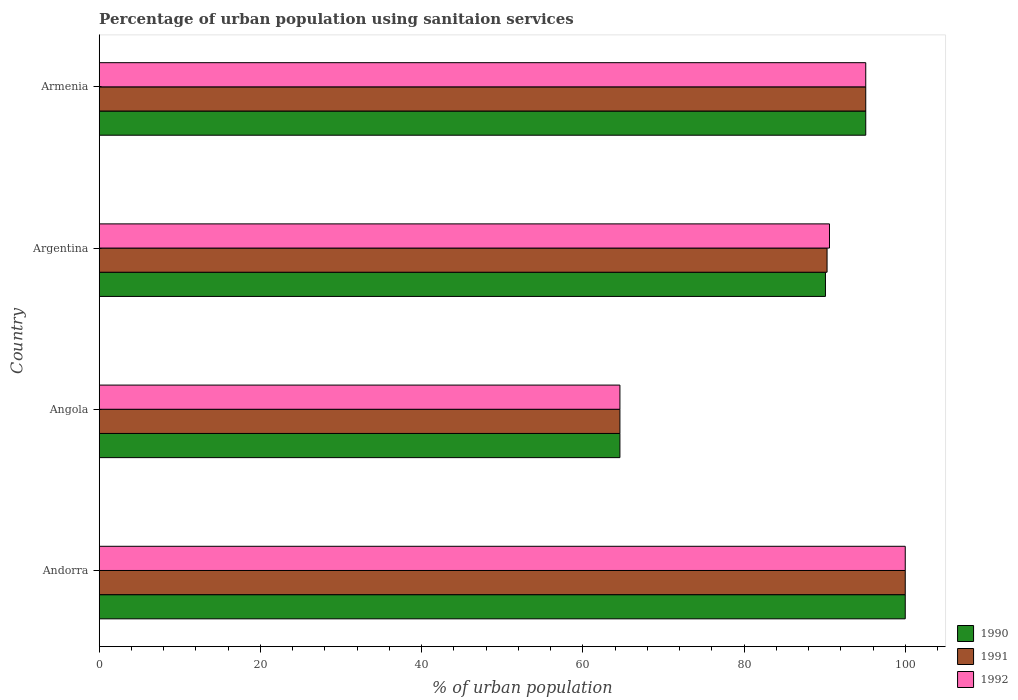How many different coloured bars are there?
Provide a short and direct response. 3. Are the number of bars per tick equal to the number of legend labels?
Keep it short and to the point. Yes. How many bars are there on the 4th tick from the top?
Make the answer very short. 3. How many bars are there on the 1st tick from the bottom?
Your response must be concise. 3. What is the label of the 2nd group of bars from the top?
Keep it short and to the point. Argentina. In how many cases, is the number of bars for a given country not equal to the number of legend labels?
Your answer should be very brief. 0. What is the percentage of urban population using sanitaion services in 1991 in Angola?
Your answer should be very brief. 64.6. Across all countries, what is the maximum percentage of urban population using sanitaion services in 1992?
Provide a succinct answer. 100. Across all countries, what is the minimum percentage of urban population using sanitaion services in 1990?
Keep it short and to the point. 64.6. In which country was the percentage of urban population using sanitaion services in 1991 maximum?
Your answer should be very brief. Andorra. In which country was the percentage of urban population using sanitaion services in 1992 minimum?
Provide a succinct answer. Angola. What is the total percentage of urban population using sanitaion services in 1991 in the graph?
Offer a terse response. 350. What is the difference between the percentage of urban population using sanitaion services in 1991 in Argentina and that in Armenia?
Offer a terse response. -4.8. What is the difference between the percentage of urban population using sanitaion services in 1992 in Argentina and the percentage of urban population using sanitaion services in 1990 in Andorra?
Provide a short and direct response. -9.4. What is the average percentage of urban population using sanitaion services in 1991 per country?
Offer a terse response. 87.5. What is the difference between the percentage of urban population using sanitaion services in 1990 and percentage of urban population using sanitaion services in 1992 in Argentina?
Provide a succinct answer. -0.5. In how many countries, is the percentage of urban population using sanitaion services in 1990 greater than 12 %?
Offer a terse response. 4. What is the ratio of the percentage of urban population using sanitaion services in 1991 in Andorra to that in Armenia?
Provide a short and direct response. 1.05. What is the difference between the highest and the second highest percentage of urban population using sanitaion services in 1990?
Your answer should be compact. 4.9. What is the difference between the highest and the lowest percentage of urban population using sanitaion services in 1990?
Ensure brevity in your answer.  35.4. In how many countries, is the percentage of urban population using sanitaion services in 1992 greater than the average percentage of urban population using sanitaion services in 1992 taken over all countries?
Offer a very short reply. 3. Is the sum of the percentage of urban population using sanitaion services in 1990 in Angola and Armenia greater than the maximum percentage of urban population using sanitaion services in 1992 across all countries?
Your answer should be compact. Yes. What does the 3rd bar from the top in Andorra represents?
Keep it short and to the point. 1990. What does the 1st bar from the bottom in Andorra represents?
Your answer should be compact. 1990. How many bars are there?
Your answer should be very brief. 12. Are all the bars in the graph horizontal?
Your answer should be very brief. Yes. Are the values on the major ticks of X-axis written in scientific E-notation?
Offer a very short reply. No. How many legend labels are there?
Provide a succinct answer. 3. What is the title of the graph?
Your answer should be compact. Percentage of urban population using sanitaion services. What is the label or title of the X-axis?
Make the answer very short. % of urban population. What is the % of urban population of 1990 in Andorra?
Ensure brevity in your answer.  100. What is the % of urban population in 1991 in Andorra?
Offer a terse response. 100. What is the % of urban population in 1992 in Andorra?
Give a very brief answer. 100. What is the % of urban population in 1990 in Angola?
Provide a succinct answer. 64.6. What is the % of urban population in 1991 in Angola?
Your answer should be very brief. 64.6. What is the % of urban population in 1992 in Angola?
Offer a terse response. 64.6. What is the % of urban population in 1990 in Argentina?
Your answer should be very brief. 90.1. What is the % of urban population of 1991 in Argentina?
Provide a short and direct response. 90.3. What is the % of urban population of 1992 in Argentina?
Provide a succinct answer. 90.6. What is the % of urban population of 1990 in Armenia?
Ensure brevity in your answer.  95.1. What is the % of urban population of 1991 in Armenia?
Make the answer very short. 95.1. What is the % of urban population of 1992 in Armenia?
Offer a terse response. 95.1. Across all countries, what is the maximum % of urban population in 1990?
Provide a succinct answer. 100. Across all countries, what is the maximum % of urban population in 1992?
Your answer should be compact. 100. Across all countries, what is the minimum % of urban population in 1990?
Your answer should be compact. 64.6. Across all countries, what is the minimum % of urban population of 1991?
Make the answer very short. 64.6. Across all countries, what is the minimum % of urban population of 1992?
Make the answer very short. 64.6. What is the total % of urban population in 1990 in the graph?
Offer a terse response. 349.8. What is the total % of urban population of 1991 in the graph?
Provide a succinct answer. 350. What is the total % of urban population in 1992 in the graph?
Your answer should be compact. 350.3. What is the difference between the % of urban population of 1990 in Andorra and that in Angola?
Offer a terse response. 35.4. What is the difference between the % of urban population of 1991 in Andorra and that in Angola?
Give a very brief answer. 35.4. What is the difference between the % of urban population in 1992 in Andorra and that in Angola?
Offer a very short reply. 35.4. What is the difference between the % of urban population of 1991 in Andorra and that in Argentina?
Give a very brief answer. 9.7. What is the difference between the % of urban population of 1992 in Andorra and that in Argentina?
Your response must be concise. 9.4. What is the difference between the % of urban population in 1990 in Andorra and that in Armenia?
Keep it short and to the point. 4.9. What is the difference between the % of urban population of 1992 in Andorra and that in Armenia?
Provide a succinct answer. 4.9. What is the difference between the % of urban population of 1990 in Angola and that in Argentina?
Offer a terse response. -25.5. What is the difference between the % of urban population in 1991 in Angola and that in Argentina?
Ensure brevity in your answer.  -25.7. What is the difference between the % of urban population in 1992 in Angola and that in Argentina?
Your answer should be compact. -26. What is the difference between the % of urban population of 1990 in Angola and that in Armenia?
Offer a very short reply. -30.5. What is the difference between the % of urban population in 1991 in Angola and that in Armenia?
Keep it short and to the point. -30.5. What is the difference between the % of urban population of 1992 in Angola and that in Armenia?
Make the answer very short. -30.5. What is the difference between the % of urban population of 1990 in Andorra and the % of urban population of 1991 in Angola?
Your response must be concise. 35.4. What is the difference between the % of urban population in 1990 in Andorra and the % of urban population in 1992 in Angola?
Your answer should be compact. 35.4. What is the difference between the % of urban population of 1991 in Andorra and the % of urban population of 1992 in Angola?
Your response must be concise. 35.4. What is the difference between the % of urban population in 1990 in Andorra and the % of urban population in 1991 in Argentina?
Give a very brief answer. 9.7. What is the difference between the % of urban population in 1991 in Andorra and the % of urban population in 1992 in Argentina?
Give a very brief answer. 9.4. What is the difference between the % of urban population in 1990 in Andorra and the % of urban population in 1991 in Armenia?
Provide a short and direct response. 4.9. What is the difference between the % of urban population in 1990 in Angola and the % of urban population in 1991 in Argentina?
Ensure brevity in your answer.  -25.7. What is the difference between the % of urban population in 1990 in Angola and the % of urban population in 1991 in Armenia?
Provide a short and direct response. -30.5. What is the difference between the % of urban population in 1990 in Angola and the % of urban population in 1992 in Armenia?
Your response must be concise. -30.5. What is the difference between the % of urban population in 1991 in Angola and the % of urban population in 1992 in Armenia?
Offer a very short reply. -30.5. What is the average % of urban population in 1990 per country?
Your response must be concise. 87.45. What is the average % of urban population of 1991 per country?
Your response must be concise. 87.5. What is the average % of urban population in 1992 per country?
Ensure brevity in your answer.  87.58. What is the difference between the % of urban population in 1990 and % of urban population in 1992 in Andorra?
Your answer should be very brief. 0. What is the difference between the % of urban population in 1991 and % of urban population in 1992 in Andorra?
Give a very brief answer. 0. What is the difference between the % of urban population in 1990 and % of urban population in 1991 in Angola?
Your answer should be very brief. 0. What is the difference between the % of urban population in 1991 and % of urban population in 1992 in Angola?
Give a very brief answer. 0. What is the difference between the % of urban population in 1990 and % of urban population in 1991 in Argentina?
Your answer should be very brief. -0.2. What is the difference between the % of urban population in 1990 and % of urban population in 1991 in Armenia?
Your answer should be compact. 0. What is the ratio of the % of urban population of 1990 in Andorra to that in Angola?
Ensure brevity in your answer.  1.55. What is the ratio of the % of urban population of 1991 in Andorra to that in Angola?
Your answer should be very brief. 1.55. What is the ratio of the % of urban population in 1992 in Andorra to that in Angola?
Your answer should be very brief. 1.55. What is the ratio of the % of urban population in 1990 in Andorra to that in Argentina?
Keep it short and to the point. 1.11. What is the ratio of the % of urban population of 1991 in Andorra to that in Argentina?
Your answer should be compact. 1.11. What is the ratio of the % of urban population in 1992 in Andorra to that in Argentina?
Give a very brief answer. 1.1. What is the ratio of the % of urban population of 1990 in Andorra to that in Armenia?
Offer a very short reply. 1.05. What is the ratio of the % of urban population in 1991 in Andorra to that in Armenia?
Keep it short and to the point. 1.05. What is the ratio of the % of urban population in 1992 in Andorra to that in Armenia?
Your response must be concise. 1.05. What is the ratio of the % of urban population of 1990 in Angola to that in Argentina?
Make the answer very short. 0.72. What is the ratio of the % of urban population of 1991 in Angola to that in Argentina?
Offer a terse response. 0.72. What is the ratio of the % of urban population in 1992 in Angola to that in Argentina?
Your answer should be compact. 0.71. What is the ratio of the % of urban population of 1990 in Angola to that in Armenia?
Offer a very short reply. 0.68. What is the ratio of the % of urban population of 1991 in Angola to that in Armenia?
Make the answer very short. 0.68. What is the ratio of the % of urban population in 1992 in Angola to that in Armenia?
Make the answer very short. 0.68. What is the ratio of the % of urban population in 1991 in Argentina to that in Armenia?
Give a very brief answer. 0.95. What is the ratio of the % of urban population of 1992 in Argentina to that in Armenia?
Offer a very short reply. 0.95. What is the difference between the highest and the second highest % of urban population in 1992?
Your answer should be very brief. 4.9. What is the difference between the highest and the lowest % of urban population of 1990?
Keep it short and to the point. 35.4. What is the difference between the highest and the lowest % of urban population in 1991?
Provide a short and direct response. 35.4. What is the difference between the highest and the lowest % of urban population in 1992?
Offer a very short reply. 35.4. 